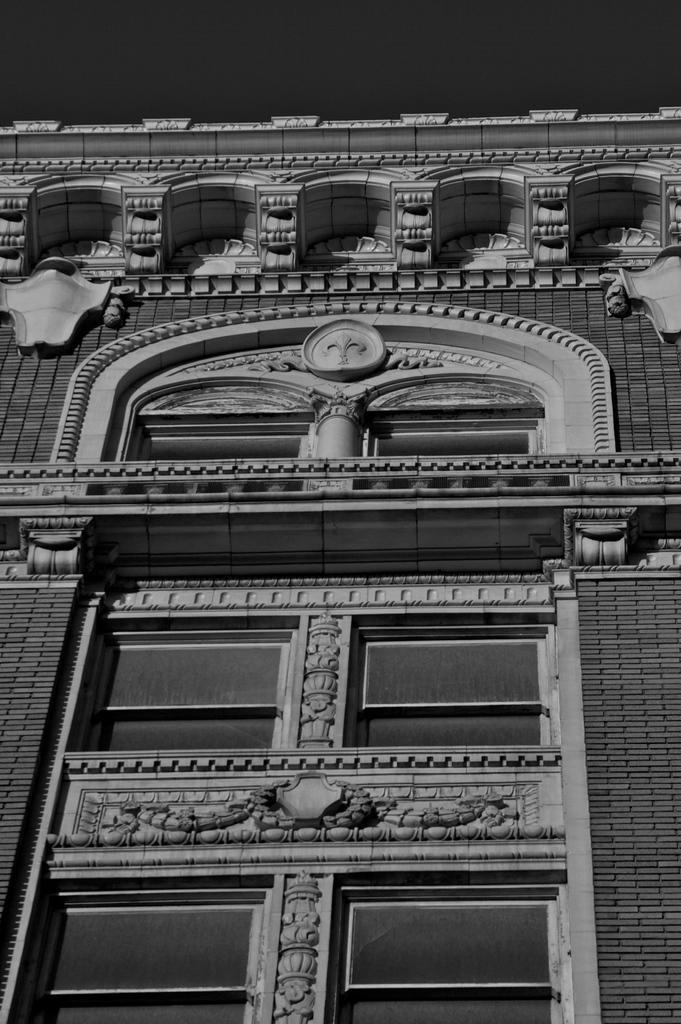How would you summarize this image in a sentence or two? In this image we can see a building. On the building we can see an arch, sculptures and windows. 